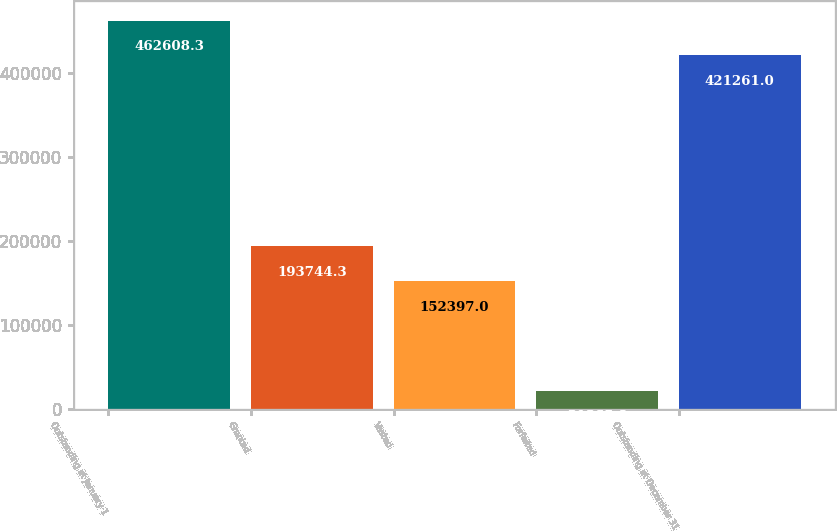Convert chart. <chart><loc_0><loc_0><loc_500><loc_500><bar_chart><fcel>Outstanding at January 1<fcel>Granted<fcel>Vested<fcel>Forfeited<fcel>Outstanding at December 31<nl><fcel>462608<fcel>193744<fcel>152397<fcel>21865<fcel>421261<nl></chart> 